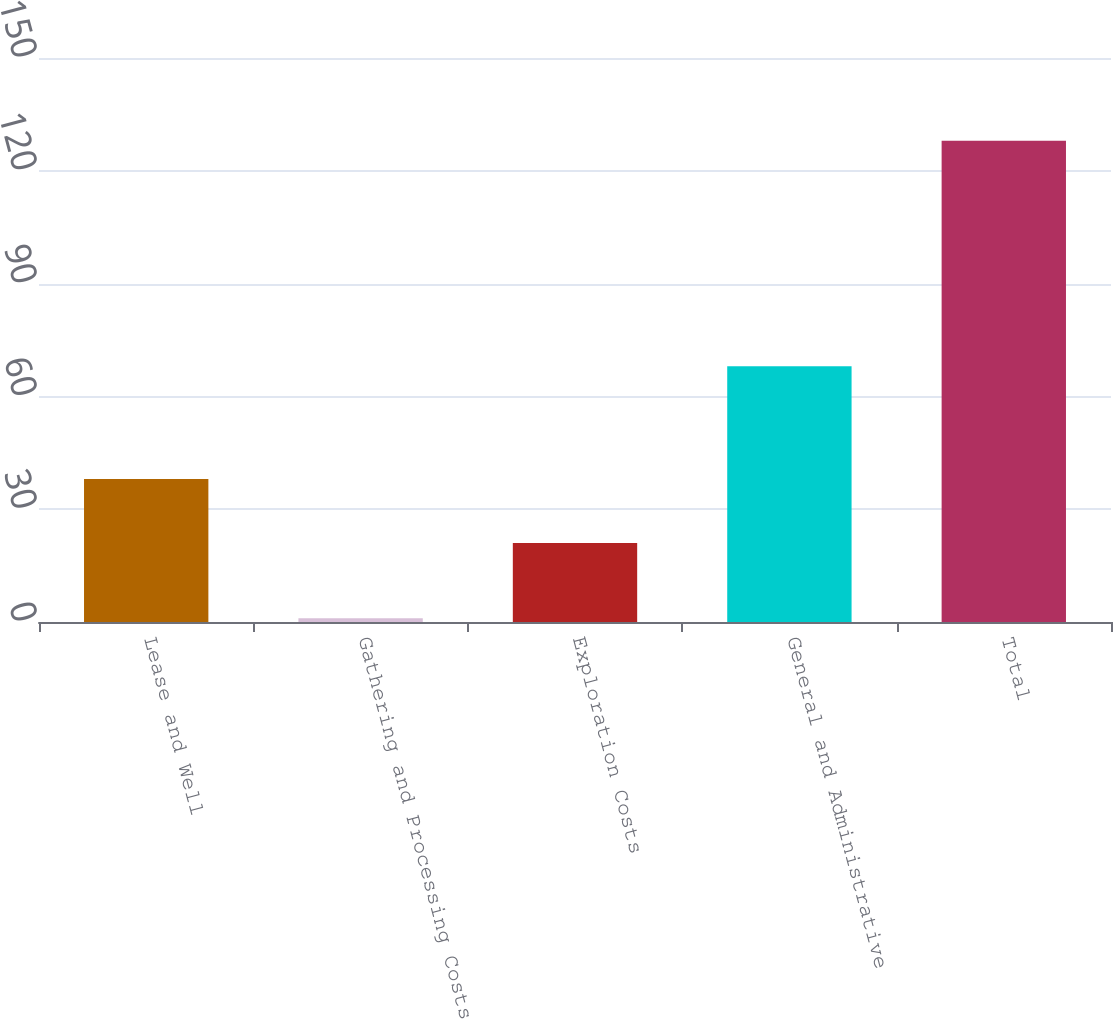Convert chart to OTSL. <chart><loc_0><loc_0><loc_500><loc_500><bar_chart><fcel>Lease and Well<fcel>Gathering and Processing Costs<fcel>Exploration Costs<fcel>General and Administrative<fcel>Total<nl><fcel>38<fcel>1<fcel>21<fcel>68<fcel>128<nl></chart> 